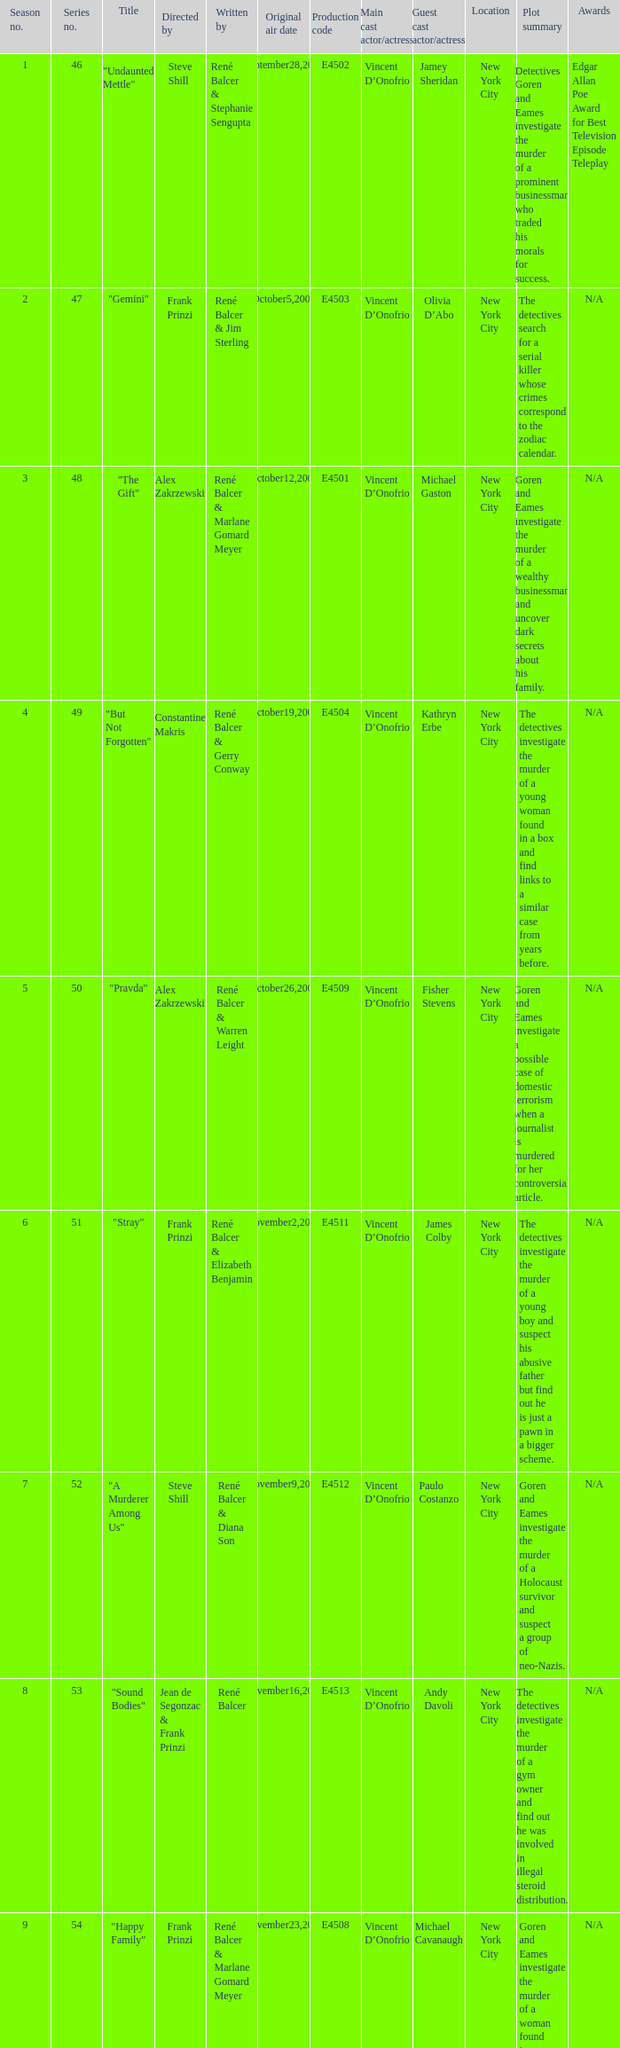Help me parse the entirety of this table. {'header': ['Season no.', 'Series no.', 'Title', 'Directed by', 'Written by', 'Original air date', 'Production code', 'Main cast actor/actress', 'Guest cast actor/actress', 'Location', 'Plot summary', 'Awards'], 'rows': [['1', '46', '"Undaunted Mettle"', 'Steve Shill', 'René Balcer & Stephanie Sengupta', 'September28,2003', 'E4502', 'Vincent D’Onofrio', 'Jamey Sheridan', 'New York City', 'Detectives Goren and Eames investigate the murder of a prominent businessman who traded his morals for success.', 'Edgar Allan Poe Award for Best Television Episode Teleplay'], ['2', '47', '"Gemini"', 'Frank Prinzi', 'René Balcer & Jim Sterling', 'October5,2003', 'E4503', 'Vincent D’Onofrio', 'Olivia D’Abo', 'New York City', 'The detectives search for a serial killer whose crimes correspond to the zodiac calendar.', 'N/A'], ['3', '48', '"The Gift"', 'Alex Zakrzewski', 'René Balcer & Marlane Gomard Meyer', 'October12,2003', 'E4501', 'Vincent D’Onofrio', 'Michael Gaston', 'New York City', 'Goren and Eames investigate the murder of a wealthy businessman and uncover dark secrets about his family.', 'N/A'], ['4', '49', '"But Not Forgotten"', 'Constantine Makris', 'René Balcer & Gerry Conway', 'October19,2003', 'E4504', 'Vincent D’Onofrio', 'Kathryn Erbe', 'New York City', 'The detectives investigate the murder of a young woman found in a box and find links to a similar case from years before.', 'N/A'], ['5', '50', '"Pravda"', 'Alex Zakrzewski', 'René Balcer & Warren Leight', 'October26,2003', 'E4509', 'Vincent D’Onofrio', 'Fisher Stevens', 'New York City', 'Goren and Eames investigate a possible case of domestic terrorism when a journalist is murdered for her controversial article.', 'N/A'], ['6', '51', '"Stray"', 'Frank Prinzi', 'René Balcer & Elizabeth Benjamin', 'November2,2003', 'E4511', 'Vincent D’Onofrio', 'James Colby', 'New York City', 'The detectives investigate the murder of a young boy and suspect his abusive father but find out he is just a pawn in a bigger scheme.', 'N/A'], ['7', '52', '"A Murderer Among Us"', 'Steve Shill', 'René Balcer & Diana Son', 'November9,2003', 'E4512', 'Vincent D’Onofrio', 'Paulo Costanzo', 'New York City', 'Goren and Eames investigate the murder of a Holocaust survivor and suspect a group of neo-Nazis.', 'N/A'], ['8', '53', '"Sound Bodies"', 'Jean de Segonzac & Frank Prinzi', 'René Balcer', 'November16,2003', 'E4513', 'Vincent D’Onofrio', 'Andy Davoli', 'New York City', 'The detectives investigate the murder of a gym owner and find out he was involved in illegal steroid distribution.', 'N/A'], ['9', '54', '"Happy Family"', 'Frank Prinzi', 'René Balcer & Marlane Gomard Meyer', 'November23,2003', 'E4508', 'Vincent D’Onofrio', 'Michael Cavanaugh', 'New York City', 'Goren and Eames investigate the murder of a woman found in a hotel room with her family and discover a twisted family dynamic.', 'N/A'], ['10', '55', '"F.P.S."', 'Darnell Martin', 'René Balcer & Gerry Conway', 'January4,2004', 'E4506', 'Vincent D’Onofrio', 'Michael Bloomberg', 'New York City', 'The detectives investigate the murder of a video game designer and find out the motive is linked to his work.', 'N/A'], ['11', '56', '"Mad Hops"', 'Christopher Swartout', 'René Balcer & Jim Sterling', 'January11,2004', 'E4514', 'Vincent D’Onofrio', 'Anthony Mackie', 'New York City', 'Goren and Eames investigate the murder of a college basketball star and find out he was involved in illegal gambling.', 'N/A'], ['12', '57', '"Unrequited"', 'Jean de Segonzac', 'René Balcer & Stephanie Sengupta', 'January18,2004', 'E4507', 'Vincent D’Onofrio', 'Kate Burton', 'New York City', 'The detectives investigate the murder of a teenage girl and become emotionally invested in the case.', 'N/A'], ['13', '58', '"Pas de Deux"', 'Frank Prinzi', 'René Balcer & Warren Leight', 'February15,2004', 'E4516', 'Vincent D’Onofrio', 'Melissa Leo', 'New York City', 'Goren and Eames investigate the murder of a ballet dancer and suspect her rival but the motive is more complicated.', 'N/A'], ['14', '59', '"Mis-Labeled"', 'Joyce Chopra', 'René Balcer & Elizabeth Benjamin', 'February22,2004', 'E4515', 'Vincent D’Onofrio', 'David Harbour', 'New York City', 'The detectives investigate the murder of a pharmacist and uncover a prescription drug ring.', 'N/A'], ['15', '60', '"Shrink-Wrapped"', 'Jean de Segonzac', 'René Balcer & Diana Son', 'March7,2004', 'E4510', 'Vincent D’Onofrio', 'Lili Taylor', 'New York City', 'Goren and Eames investigate the murder of a psychiatrist and suspect one of his patients but the motive is unexpected.', 'N/A'], ['16', '61', '"The Saint"', 'Frank Prinzi', 'René Balcer & Marlane Gomard Meyer', 'March14,2004', 'E4517', 'Vincent D’Onofrio', 'Joe Morton', 'New York City', 'The detectives investigate the murder of a Nigerian man and become tangled in international politics.', 'N/A'], ['17', '62', '"Conscience"', 'Alex Chapple', 'René Balcer & Gerry Conway', 'March28,2004', 'E4519', 'Vincent D’Onofrio', 'Marley Shelton', 'New York City', 'Goren and Eames investigate the murder of a celebrity chef and suspect his protege but the motive is personal.', 'N/A'], ['18', '63', '"Ill-Bred"', 'Steve Shill', 'René Balcer & Jim Sterling', 'April18,2004', 'E4520', 'Vincent D’Onofrio', 'James Badge Dale', 'New York City', 'The detectives investigate the murder of a socialite and suspect her husband but the motive is hidden in her past.', 'N/A'], ['19', '64', '"Fico di Capo"', 'Alex Zakrzewski', 'René Balcer & Stephanie Sengupta', 'May9,2004', 'E4518', 'Vincent D’Onofrio', 'Susan Misner', 'New York City', 'Goren and Eames investigate the murder of a noted wine connoisseur and find out the motive is linked to his connection to the mob.', 'N/A'], ['20', '65', '"D.A.W."', 'Frank Prinzi', 'René Balcer & Warren Leight', 'May16,2004', 'E4522', 'Vincent D’Onofrio', 'Jennifer Esposito', 'New York City', 'The detectives investigate the murder of a businesswoman and find out the motive is related to her shady business dealings.', 'N/A']]} What episode number in the season is titled "stray"? 6.0. 